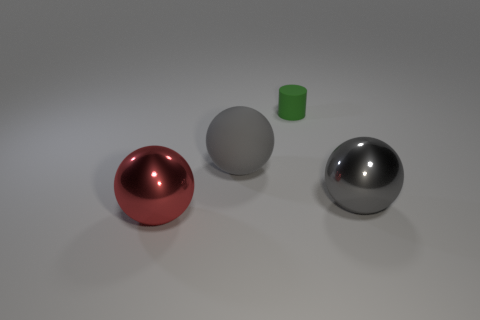What number of things are either green objects or big matte things?
Your answer should be compact. 2. There is a matte thing that is in front of the tiny rubber thing; are there any big rubber balls to the right of it?
Your answer should be compact. No. Are there more cylinders that are in front of the red metallic sphere than shiny balls that are on the right side of the small green object?
Offer a terse response. No. What is the material of the other large ball that is the same color as the rubber ball?
Ensure brevity in your answer.  Metal. How many large shiny things are the same color as the matte sphere?
Provide a succinct answer. 1. Do the metal sphere behind the big red thing and the metal sphere that is to the left of the tiny object have the same color?
Offer a very short reply. No. There is a red sphere; are there any red objects in front of it?
Ensure brevity in your answer.  No. What is the green cylinder made of?
Provide a short and direct response. Rubber. There is a thing behind the gray matte object; what shape is it?
Ensure brevity in your answer.  Cylinder. What is the size of the other sphere that is the same color as the matte sphere?
Your response must be concise. Large. 